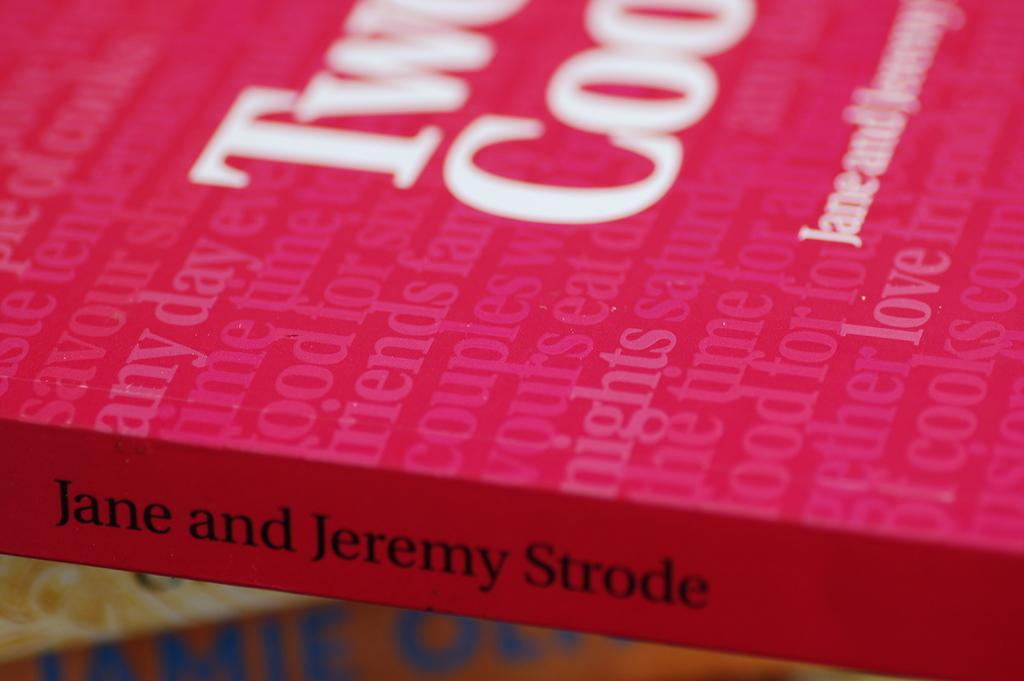Provide a one-sentence caption for the provided image. A red book with pink and white lettering text by Jane and Jeremy Strode. 